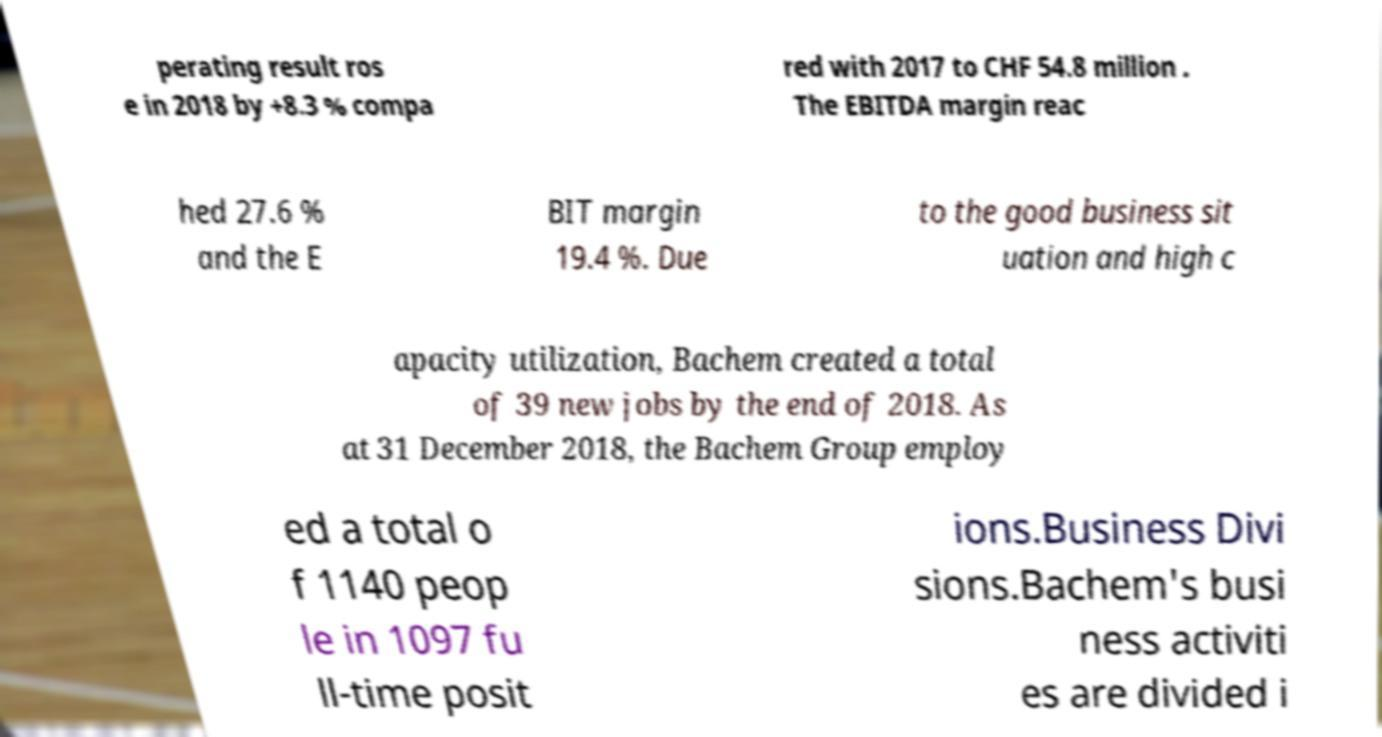Please read and relay the text visible in this image. What does it say? perating result ros e in 2018 by +8.3 % compa red with 2017 to CHF 54.8 million . The EBITDA margin reac hed 27.6 % and the E BIT margin 19.4 %. Due to the good business sit uation and high c apacity utilization, Bachem created a total of 39 new jobs by the end of 2018. As at 31 December 2018, the Bachem Group employ ed a total o f 1140 peop le in 1097 fu ll-time posit ions.Business Divi sions.Bachem's busi ness activiti es are divided i 